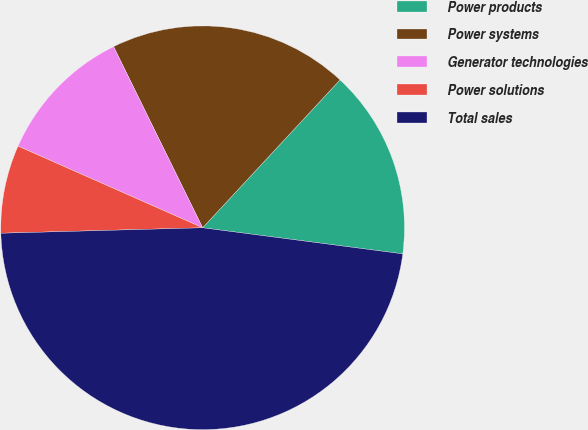<chart> <loc_0><loc_0><loc_500><loc_500><pie_chart><fcel>Power products<fcel>Power systems<fcel>Generator technologies<fcel>Power solutions<fcel>Total sales<nl><fcel>15.15%<fcel>19.19%<fcel>11.1%<fcel>7.06%<fcel>47.51%<nl></chart> 